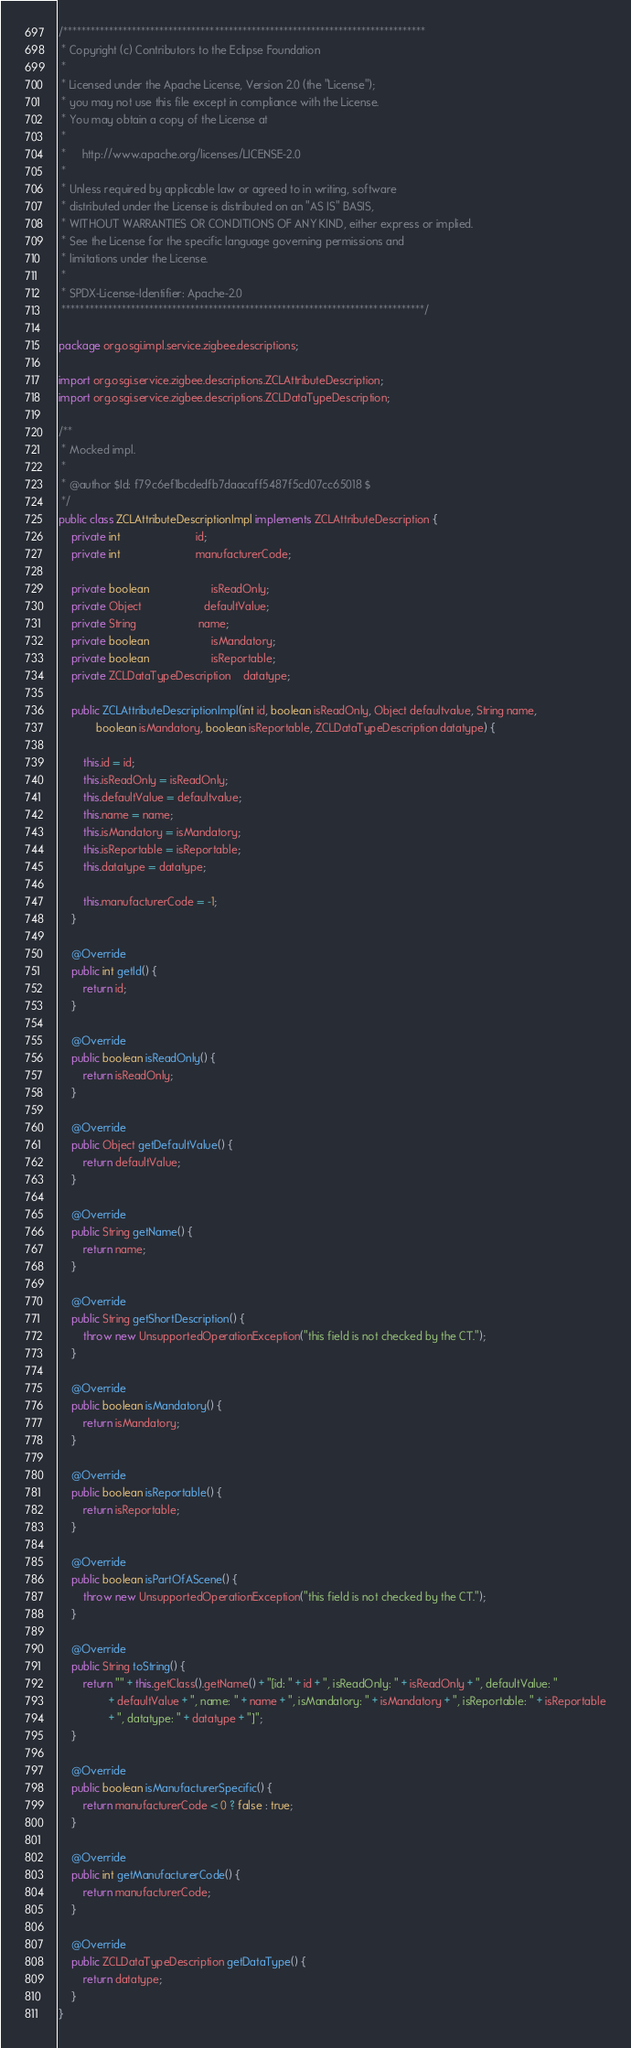Convert code to text. <code><loc_0><loc_0><loc_500><loc_500><_Java_>/*******************************************************************************
 * Copyright (c) Contributors to the Eclipse Foundation
 *
 * Licensed under the Apache License, Version 2.0 (the "License");
 * you may not use this file except in compliance with the License.
 * You may obtain a copy of the License at
 *
 *     http://www.apache.org/licenses/LICENSE-2.0
 *
 * Unless required by applicable law or agreed to in writing, software
 * distributed under the License is distributed on an "AS IS" BASIS,
 * WITHOUT WARRANTIES OR CONDITIONS OF ANY KIND, either express or implied.
 * See the License for the specific language governing permissions and
 * limitations under the License.
 *
 * SPDX-License-Identifier: Apache-2.0 
 *******************************************************************************/

package org.osgi.impl.service.zigbee.descriptions;

import org.osgi.service.zigbee.descriptions.ZCLAttributeDescription;
import org.osgi.service.zigbee.descriptions.ZCLDataTypeDescription;

/**
 * Mocked impl.
 * 
 * @author $Id: f79c6ef1bcdedfb7daacaff5487f5cd07cc65018 $
 */
public class ZCLAttributeDescriptionImpl implements ZCLAttributeDescription {
	private int						id;
	private int						manufacturerCode;

	private boolean					isReadOnly;
	private Object					defaultValue;
	private String					name;
	private boolean					isMandatory;
	private boolean					isReportable;
	private ZCLDataTypeDescription	datatype;

	public ZCLAttributeDescriptionImpl(int id, boolean isReadOnly, Object defaultvalue, String name,
			boolean isMandatory, boolean isReportable, ZCLDataTypeDescription datatype) {

		this.id = id;
		this.isReadOnly = isReadOnly;
		this.defaultValue = defaultvalue;
		this.name = name;
		this.isMandatory = isMandatory;
		this.isReportable = isReportable;
		this.datatype = datatype;

		this.manufacturerCode = -1;
	}

	@Override
	public int getId() {
		return id;
	}

	@Override
	public boolean isReadOnly() {
		return isReadOnly;
	}

	@Override
	public Object getDefaultValue() {
		return defaultValue;
	}

	@Override
	public String getName() {
		return name;
	}

	@Override
	public String getShortDescription() {
		throw new UnsupportedOperationException("this field is not checked by the CT.");
	}

	@Override
	public boolean isMandatory() {
		return isMandatory;
	}

	@Override
	public boolean isReportable() {
		return isReportable;
	}

	@Override
	public boolean isPartOfAScene() {
		throw new UnsupportedOperationException("this field is not checked by the CT.");
	}

	@Override
	public String toString() {
		return "" + this.getClass().getName() + "[id: " + id + ", isReadOnly: " + isReadOnly + ", defaultValue: "
				+ defaultValue + ", name: " + name + ", isMandatory: " + isMandatory + ", isReportable: " + isReportable
				+ ", datatype: " + datatype + "]";
	}

	@Override
	public boolean isManufacturerSpecific() {
		return manufacturerCode < 0 ? false : true;
	}

	@Override
	public int getManufacturerCode() {
		return manufacturerCode;
	}

	@Override
	public ZCLDataTypeDescription getDataType() {
		return datatype;
	}
}
</code> 